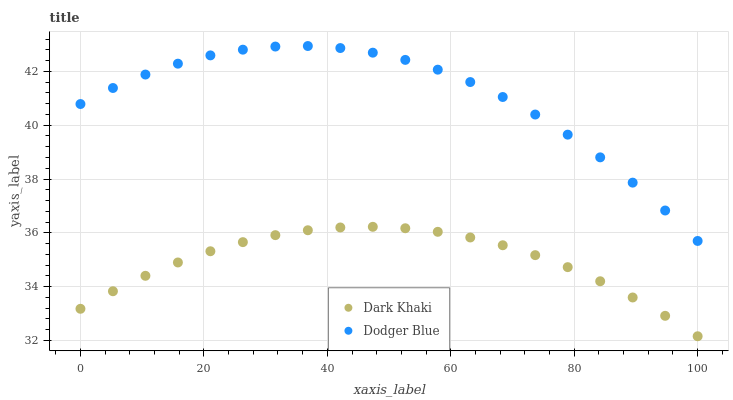Does Dark Khaki have the minimum area under the curve?
Answer yes or no. Yes. Does Dodger Blue have the maximum area under the curve?
Answer yes or no. Yes. Does Dodger Blue have the minimum area under the curve?
Answer yes or no. No. Is Dark Khaki the smoothest?
Answer yes or no. Yes. Is Dodger Blue the roughest?
Answer yes or no. Yes. Is Dodger Blue the smoothest?
Answer yes or no. No. Does Dark Khaki have the lowest value?
Answer yes or no. Yes. Does Dodger Blue have the lowest value?
Answer yes or no. No. Does Dodger Blue have the highest value?
Answer yes or no. Yes. Is Dark Khaki less than Dodger Blue?
Answer yes or no. Yes. Is Dodger Blue greater than Dark Khaki?
Answer yes or no. Yes. Does Dark Khaki intersect Dodger Blue?
Answer yes or no. No. 